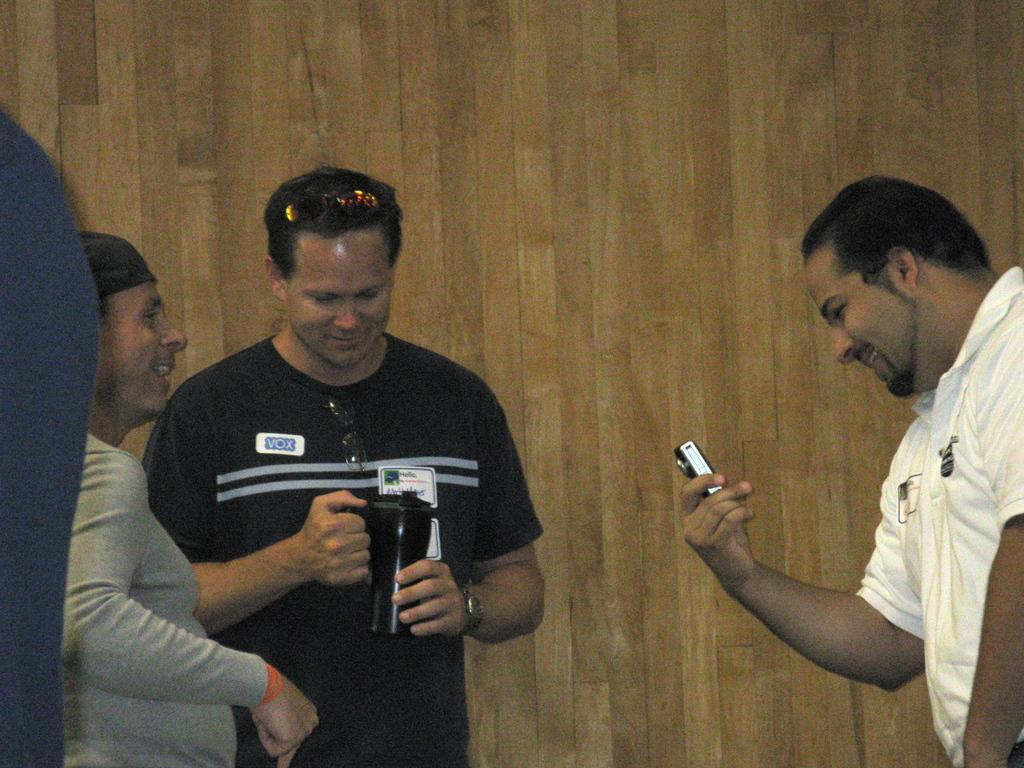How many people are in the image? There are three persons in the image. What is one person holding in the image? One person is holding a camera. What is another person holding in the image? Another person is holding a bottle. What can be seen in the background of the image? There is a wooden wall in the background of the image. What type of art is the cook wearing in the image? There is no cook or art present in the image. What color is the underwear of the person holding the bottle? There is no information about the person's underwear in the image, as it is not visible or mentioned in the provided facts. 